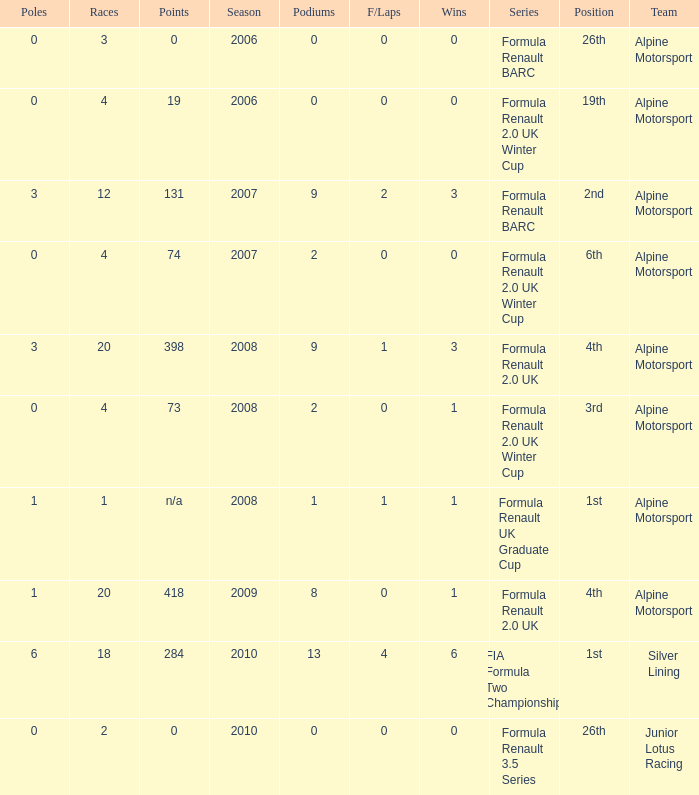What was the earliest season where podium was 9? 2007.0. 